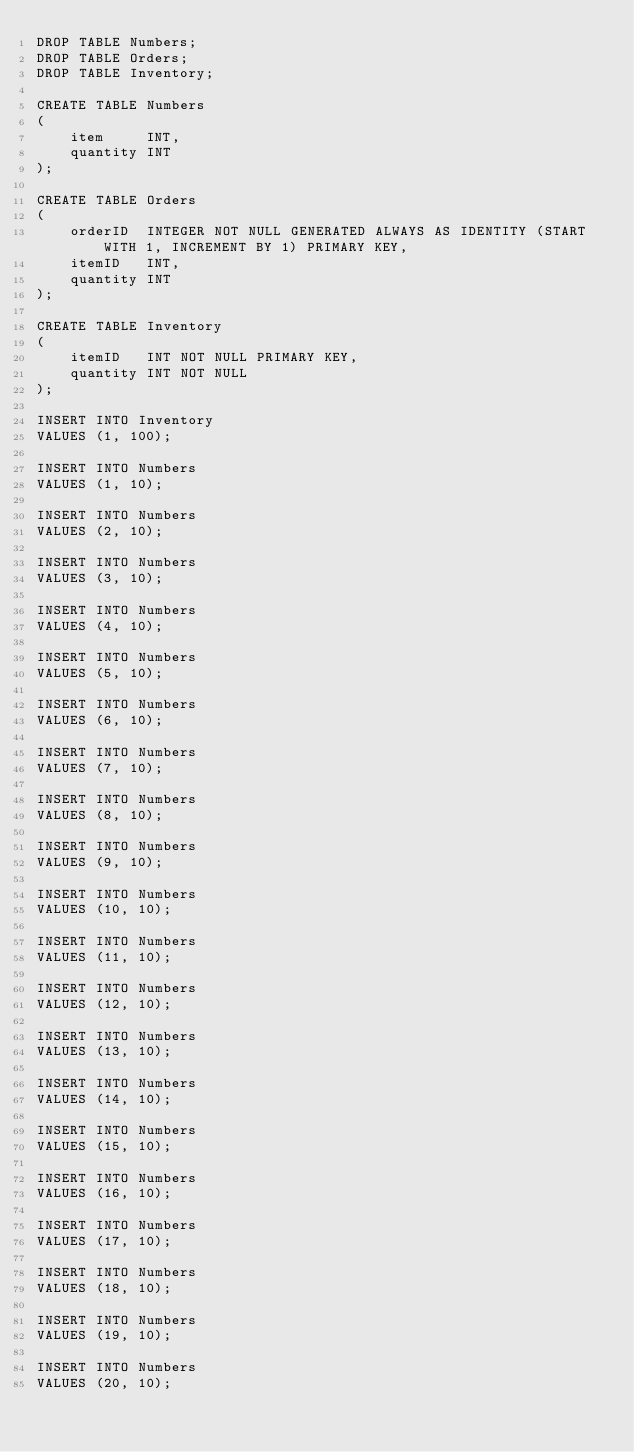<code> <loc_0><loc_0><loc_500><loc_500><_SQL_>DROP TABLE Numbers;
DROP TABLE Orders;
DROP TABLE Inventory;

CREATE TABLE Numbers
(
    item     INT,
    quantity INT
);

CREATE TABLE Orders
(
    orderID  INTEGER NOT NULL GENERATED ALWAYS AS IDENTITY (START WITH 1, INCREMENT BY 1) PRIMARY KEY,
    itemID   INT,
    quantity INT
);

CREATE TABLE Inventory
(
    itemID   INT NOT NULL PRIMARY KEY,
    quantity INT NOT NULL
);

INSERT INTO Inventory
VALUES (1, 100);

INSERT INTO Numbers
VALUES (1, 10);

INSERT INTO Numbers
VALUES (2, 10);

INSERT INTO Numbers
VALUES (3, 10);

INSERT INTO Numbers
VALUES (4, 10);

INSERT INTO Numbers
VALUES (5, 10);

INSERT INTO Numbers
VALUES (6, 10);

INSERT INTO Numbers
VALUES (7, 10);

INSERT INTO Numbers
VALUES (8, 10);

INSERT INTO Numbers
VALUES (9, 10);

INSERT INTO Numbers
VALUES (10, 10);

INSERT INTO Numbers
VALUES (11, 10);

INSERT INTO Numbers
VALUES (12, 10);

INSERT INTO Numbers
VALUES (13, 10);

INSERT INTO Numbers
VALUES (14, 10);

INSERT INTO Numbers
VALUES (15, 10);

INSERT INTO Numbers
VALUES (16, 10);

INSERT INTO Numbers
VALUES (17, 10);

INSERT INTO Numbers
VALUES (18, 10);

INSERT INTO Numbers
VALUES (19, 10);

INSERT INTO Numbers
VALUES (20, 10);
</code> 